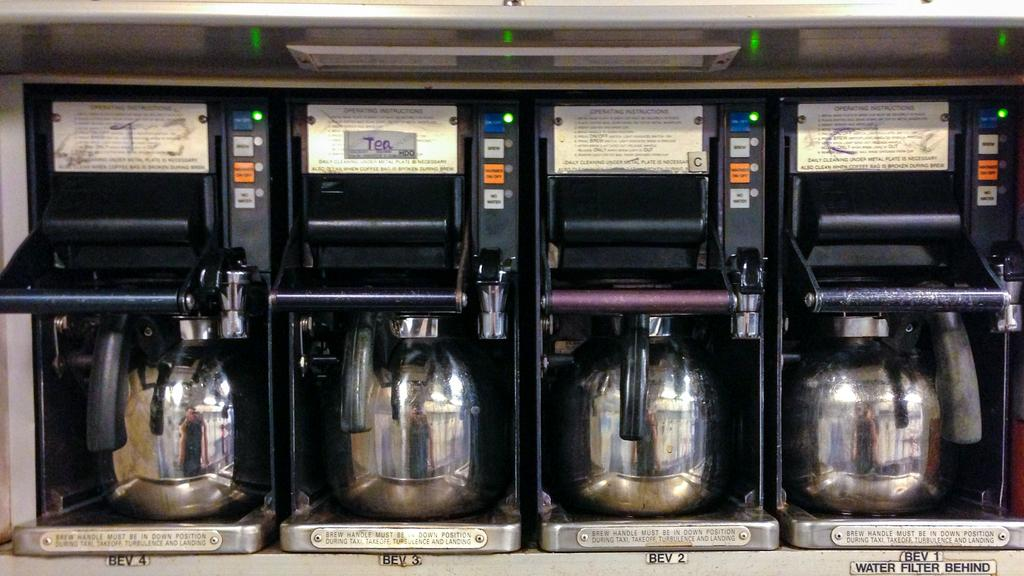<image>
Summarize the visual content of the image. a set of drink dispensers, with Bev 1 also saying Water Filter behind. 